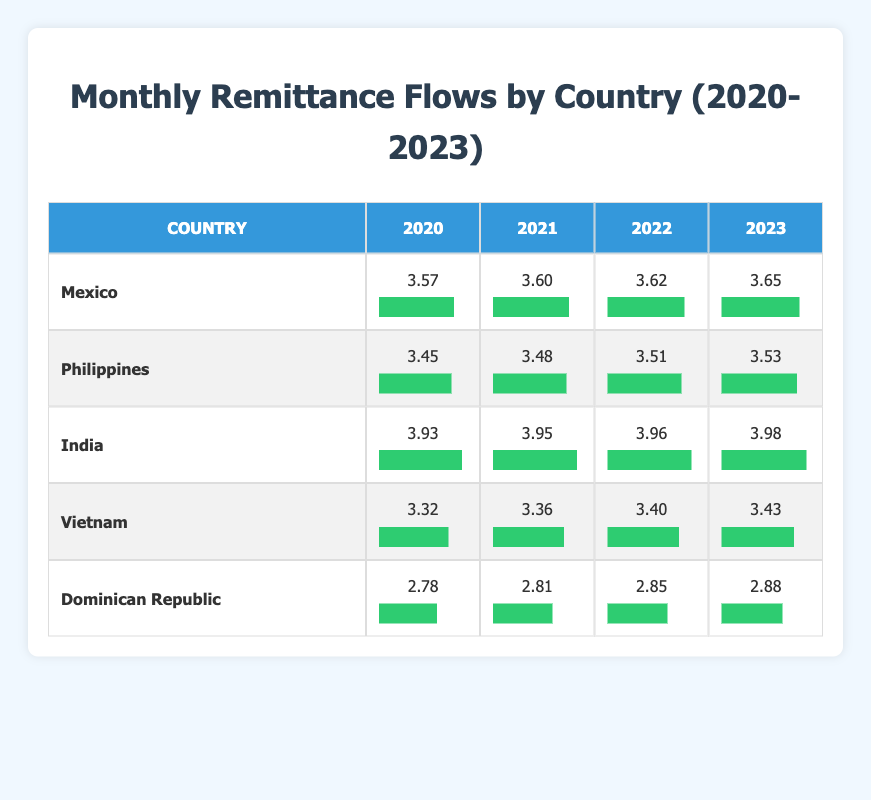What was the monthly remittance flow from India in 2023? The table shows that the monthly remittance flow from India in 2023 is 3.98.
Answer: 3.98 Which country had the highest monthly remittance flow in 2022? By comparing the values in the 2022 column, India has the highest amount at 3.96, followed by Mexico at 3.62.
Answer: India What is the difference in monthly remittance flow from Mexico between 2020 and 2023? To find the difference, subtract the 2020 figure (3.57) from the 2023 figure (3.65). This gives us 3.65 - 3.57 = 0.08.
Answer: 0.08 Did the monthly remittance flow from the Dominican Republic increase every year from 2020 to 2023? Checking the values in the table, the monthly remittance for the Dominican Republic increased from 2.78 in 2020 to 2.88 in 2023. Thus, it increased every year.
Answer: Yes What is the average monthly remittance flow across all countries in 2021? Calculate the average by adding the remittance flows in 2021 (3.60 + 3.48 + 3.95 + 3.36 + 2.81) and dividing by the number of countries (5). The sum is 17.20, and the average is 17.20 / 5 = 3.44.
Answer: 3.44 What was the monthly remittance flow from Vietnam in 2020? The table indicates that the monthly remittance flow from Vietnam in 2020 is 3.32.
Answer: 3.32 Which countries had a monthly remittance flow above 3.5 in 2023? Looking at the 2023 column, India (3.98), Mexico (3.65), and the Philippines (3.53) are the countries with flows above 3.5 in 2023.
Answer: India, Mexico, Philippines Was the increase in monthly remittance flow from the Philippines from 2020 to 2023 greater than that of the Dominican Republic? For the Philippines, the increase is 3.53 - 3.45 = 0.08. For the Dominican Republic, it is 2.88 - 2.78 = 0.10. Thus, the increase for the Dominican Republic (0.10) was greater than for the Philippines (0.08).
Answer: No 